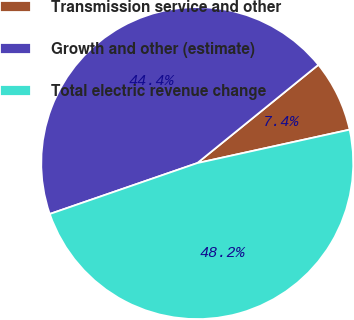<chart> <loc_0><loc_0><loc_500><loc_500><pie_chart><fcel>Transmission service and other<fcel>Growth and other (estimate)<fcel>Total electric revenue change<nl><fcel>7.41%<fcel>44.44%<fcel>48.15%<nl></chart> 